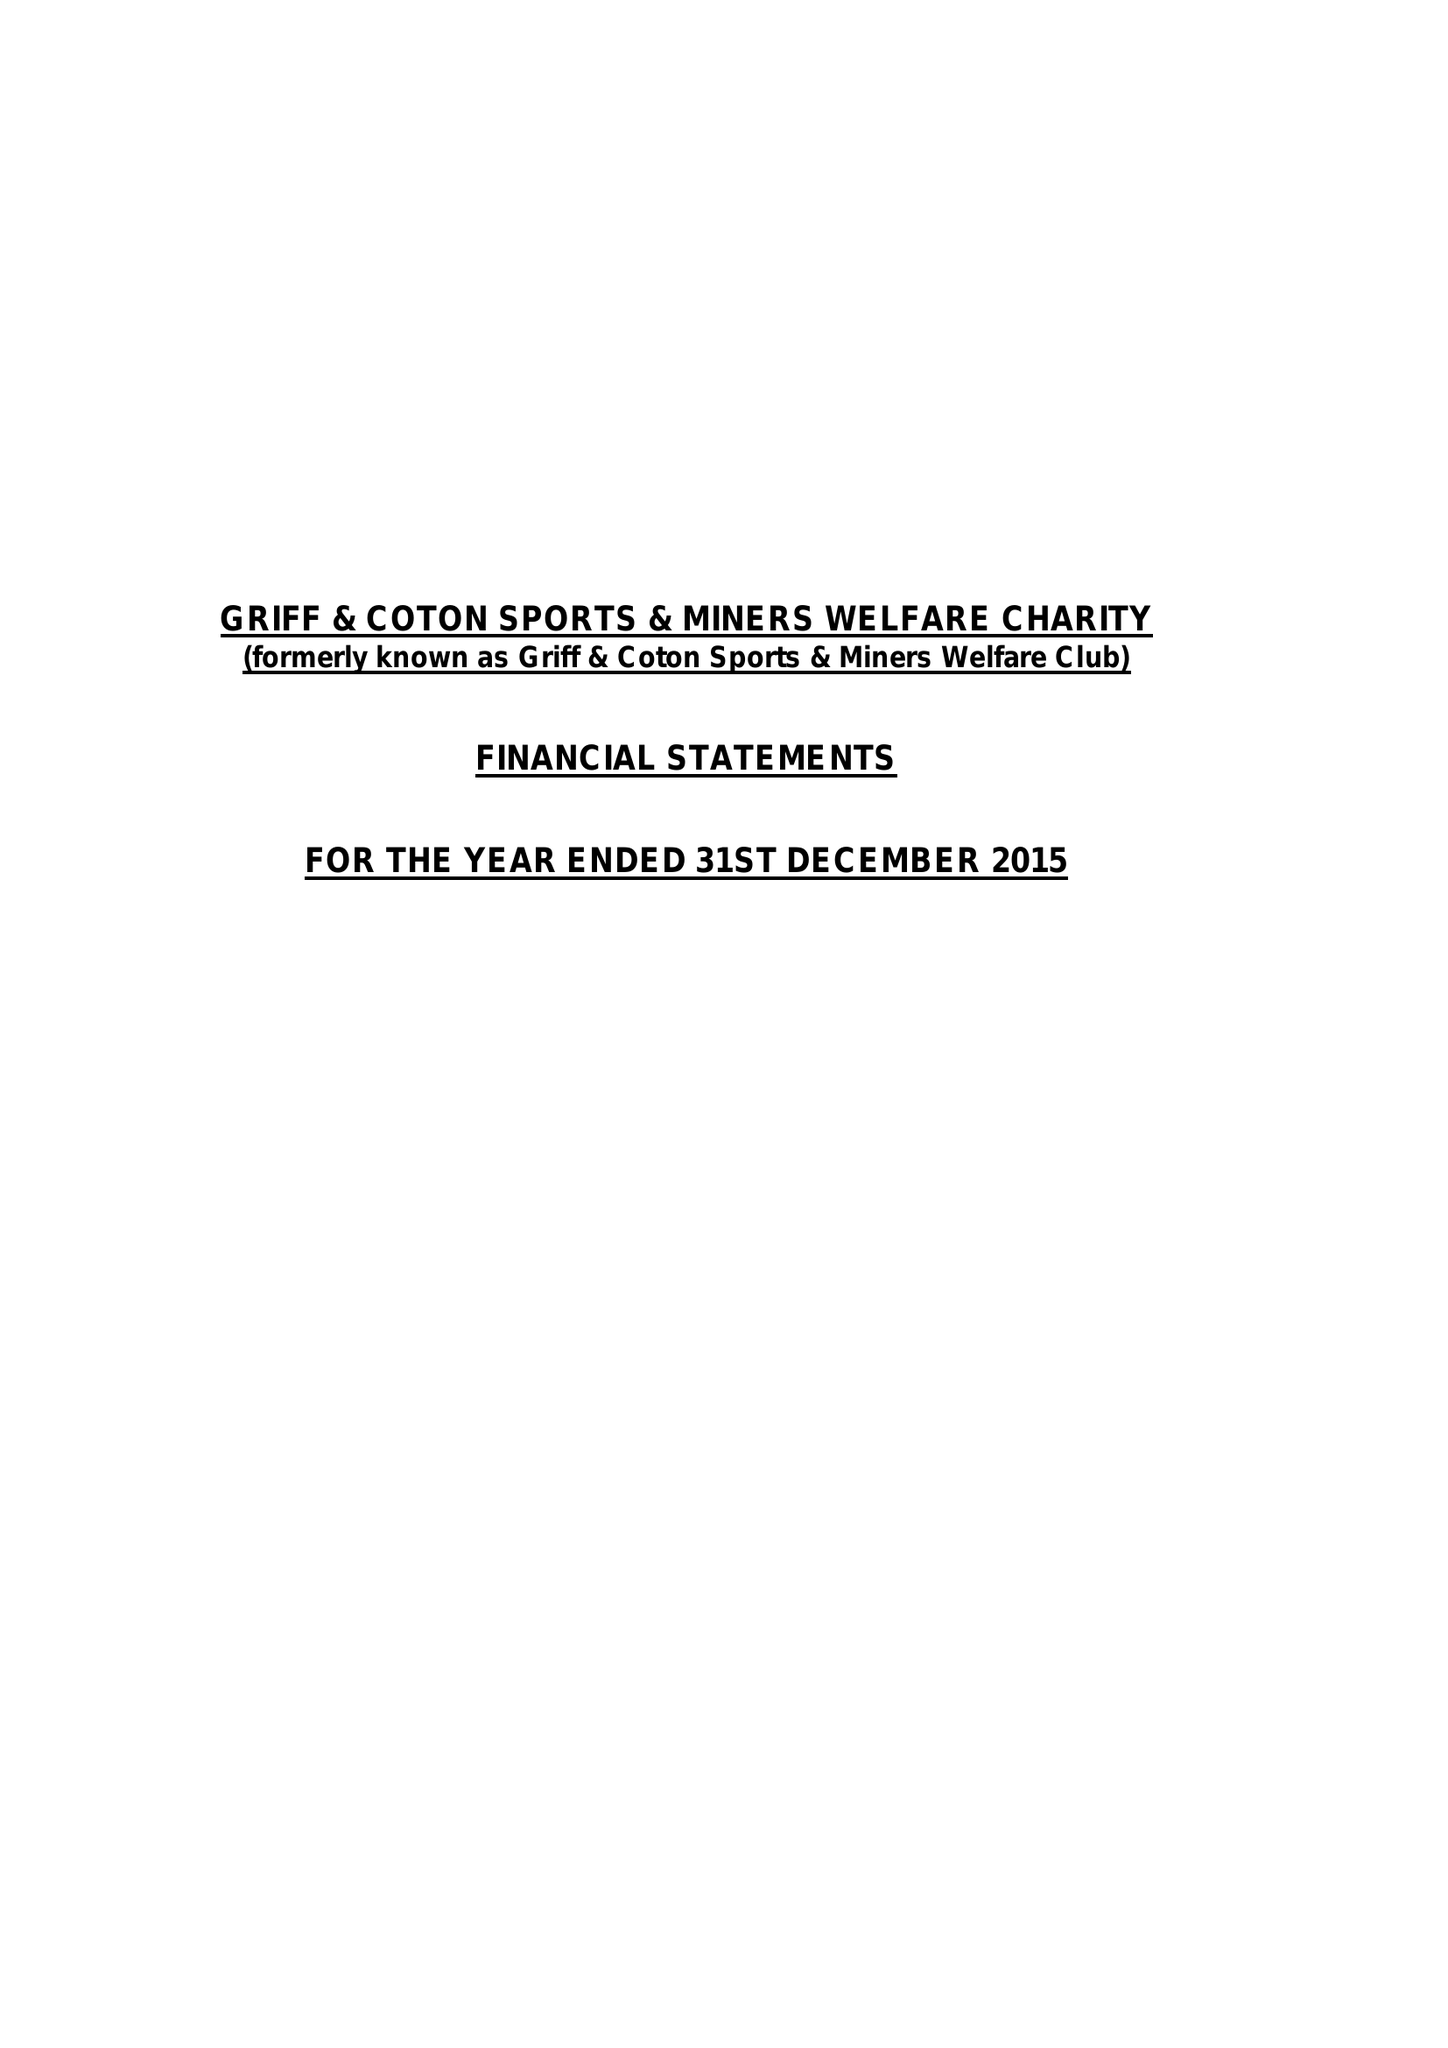What is the value for the report_date?
Answer the question using a single word or phrase. 2015-12-31 